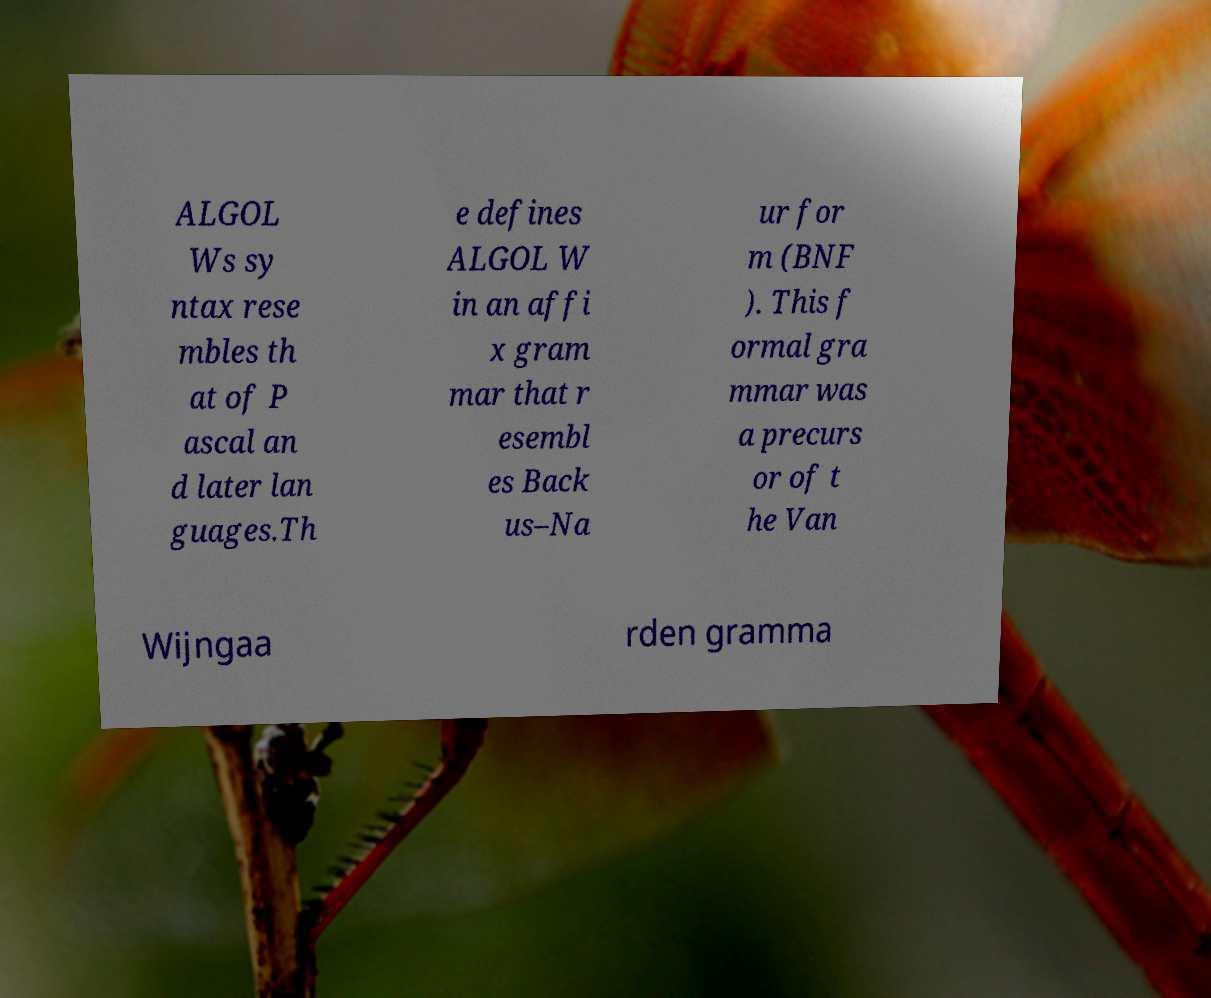Can you read and provide the text displayed in the image?This photo seems to have some interesting text. Can you extract and type it out for me? ALGOL Ws sy ntax rese mbles th at of P ascal an d later lan guages.Th e defines ALGOL W in an affi x gram mar that r esembl es Back us–Na ur for m (BNF ). This f ormal gra mmar was a precurs or of t he Van Wijngaa rden gramma 